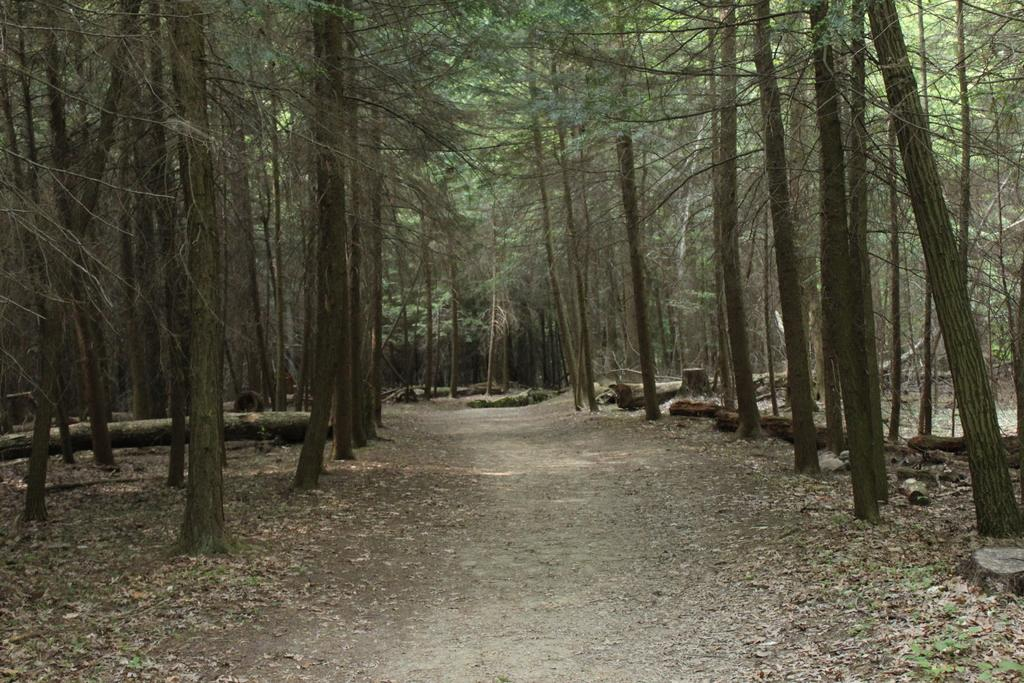What type of vegetation can be seen in the image? There are trees in the image. What material are the barks made of in the image? There are wooden barks in the image. What type of sponge can be seen in the image? There is no sponge present in the image. What type of crack is visible in the image? There is no crack visible in the image. 